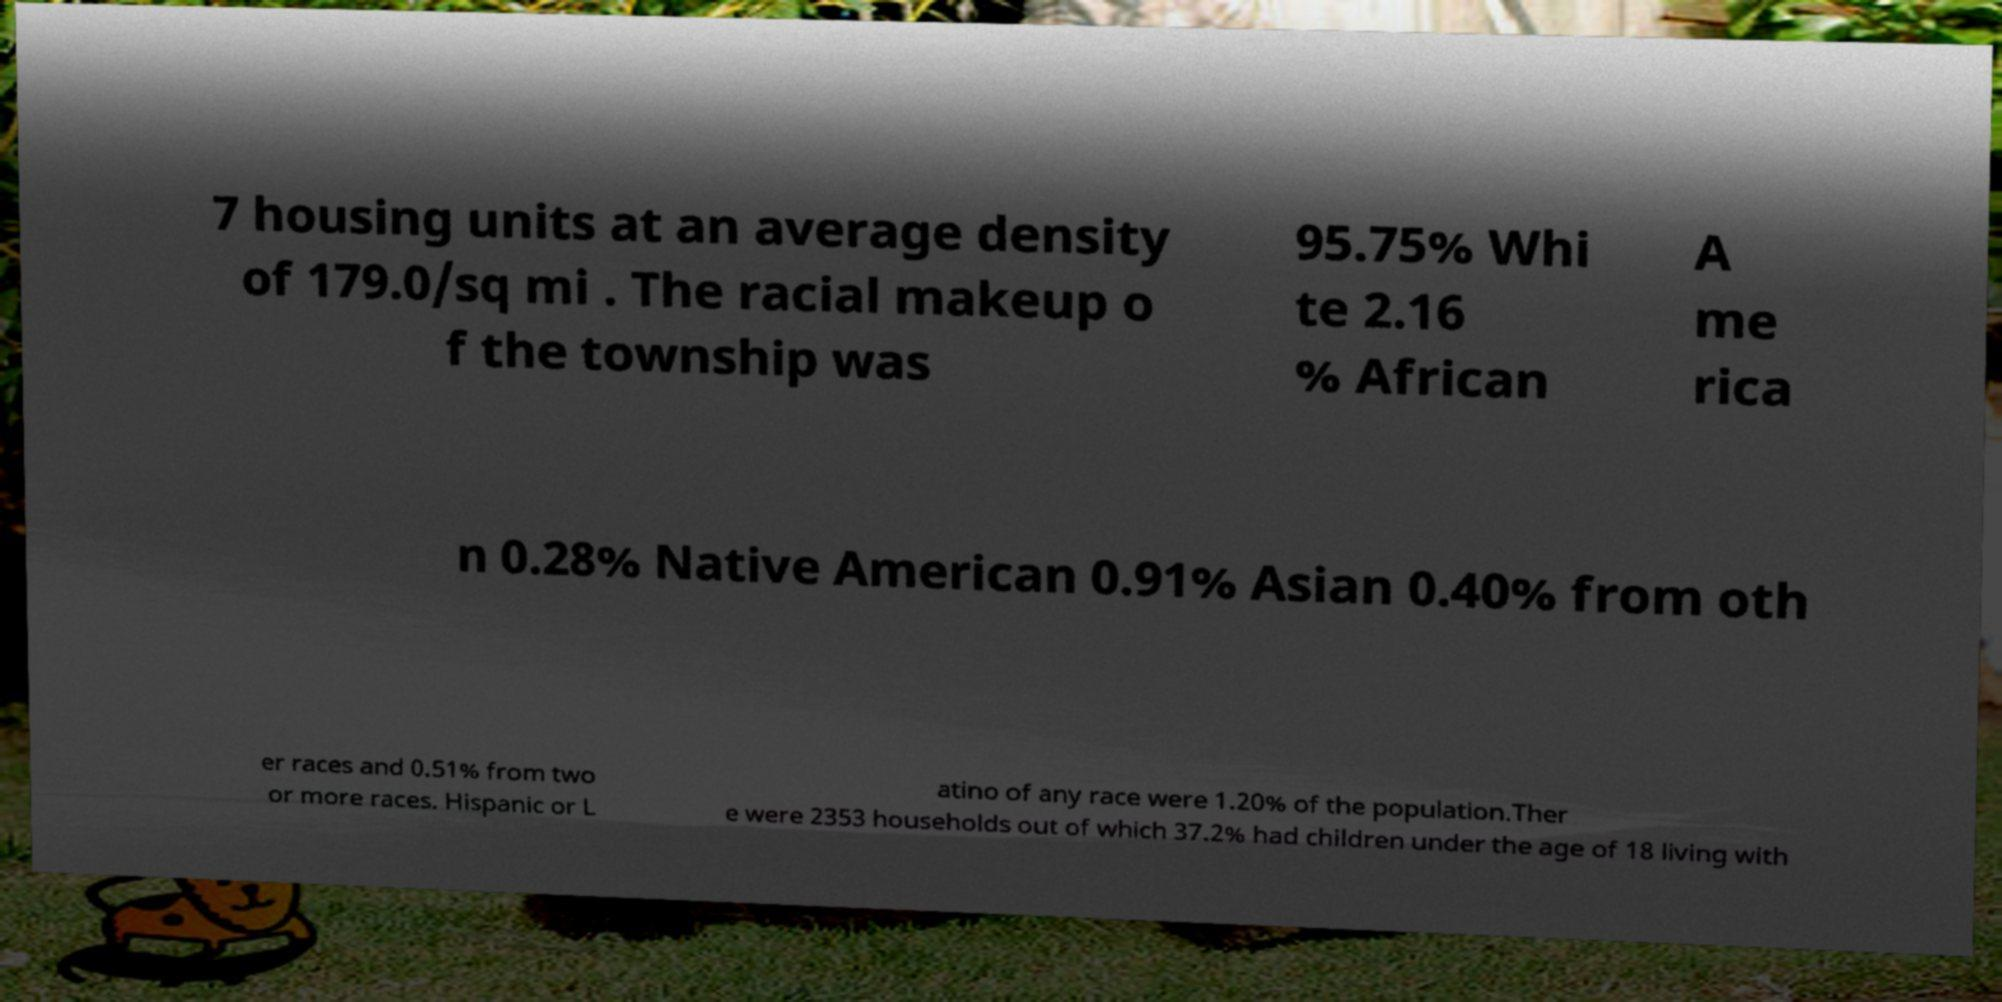Please identify and transcribe the text found in this image. 7 housing units at an average density of 179.0/sq mi . The racial makeup o f the township was 95.75% Whi te 2.16 % African A me rica n 0.28% Native American 0.91% Asian 0.40% from oth er races and 0.51% from two or more races. Hispanic or L atino of any race were 1.20% of the population.Ther e were 2353 households out of which 37.2% had children under the age of 18 living with 